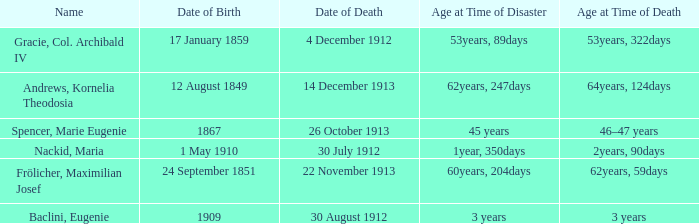What is the name of the person born in 1909? Baclini, Eugenie. 